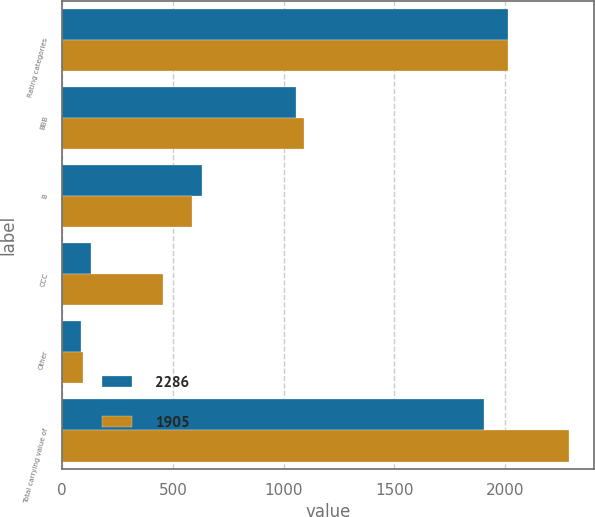Convert chart to OTSL. <chart><loc_0><loc_0><loc_500><loc_500><stacked_bar_chart><ecel><fcel>Rating categories<fcel>BBB<fcel>B<fcel>CCC<fcel>Other<fcel>Total carrying value of<nl><fcel>2286<fcel>2014<fcel>1055<fcel>633<fcel>131<fcel>86<fcel>1905<nl><fcel>1905<fcel>2013<fcel>1091<fcel>585<fcel>457<fcel>95<fcel>2286<nl></chart> 